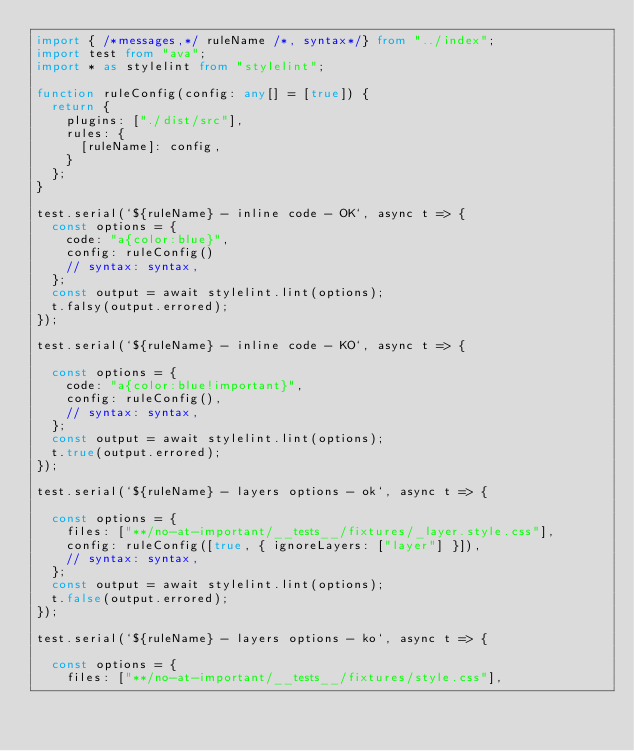<code> <loc_0><loc_0><loc_500><loc_500><_TypeScript_>import { /*messages,*/ ruleName /*, syntax*/} from "../index";
import test from "ava";
import * as stylelint from "stylelint";

function ruleConfig(config: any[] = [true]) {
  return {
    plugins: ["./dist/src"],
    rules: {
      [ruleName]: config,
    }
  };
}

test.serial(`${ruleName} - inline code - OK`, async t => {
  const options = {
    code: "a{color:blue}",
    config: ruleConfig()
    // syntax: syntax,
  };
  const output = await stylelint.lint(options);
  t.falsy(output.errored);
});

test.serial(`${ruleName} - inline code - KO`, async t => {

  const options = {
    code: "a{color:blue!important}",
    config: ruleConfig(),
    // syntax: syntax,
  };
  const output = await stylelint.lint(options);
  t.true(output.errored);
});

test.serial(`${ruleName} - layers options - ok`, async t => {

  const options = {
    files: ["**/no-at-important/__tests__/fixtures/_layer.style.css"],
    config: ruleConfig([true, { ignoreLayers: ["layer"] }]),
    // syntax: syntax,
  };
  const output = await stylelint.lint(options);
  t.false(output.errored);
});

test.serial(`${ruleName} - layers options - ko`, async t => {

  const options = {
    files: ["**/no-at-important/__tests__/fixtures/style.css"],</code> 